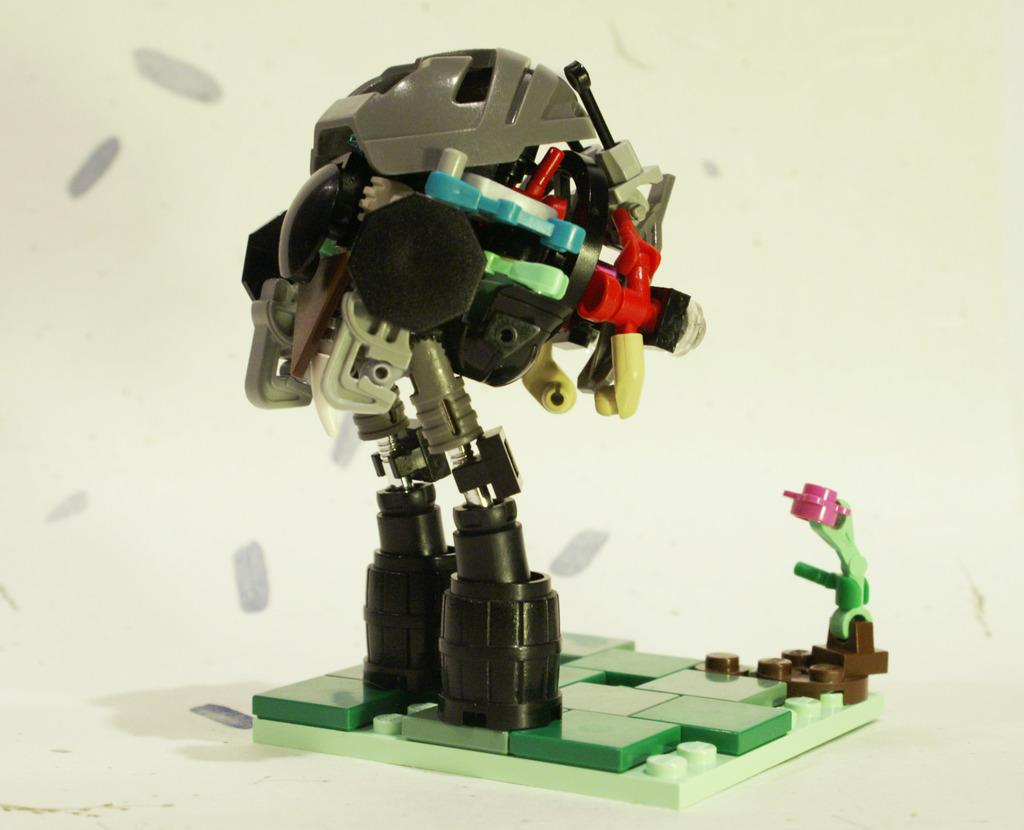What is the main subject in the center of the image? There is a robot toy in the center of the image. What can be seen in the background of the image? There is a plain surface in the background of the image. What type of question is the robot toy asking in the image? There is no indication in the image that the robot toy is asking a question or capable of doing so. 